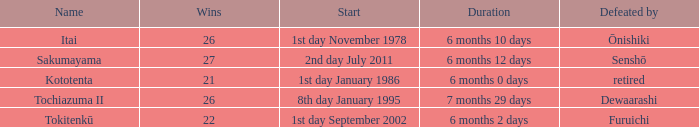Which Start has a Duration of 6 months 2 days? 1st day September 2002. 